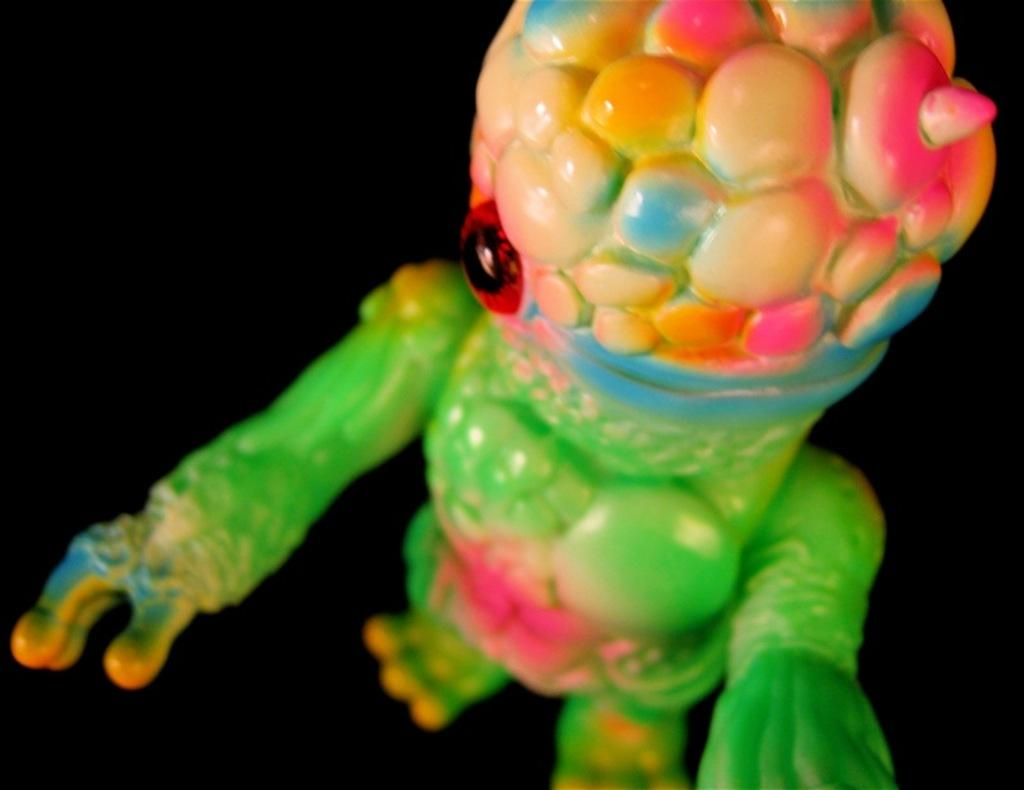What object can be seen in the image? There is a toy in the image. What can be observed about the background of the image? The background of the image is dark. What type of owl is sitting on the toy in the image? There is no owl present in the image; it only features a toy. Can you tell me how many boots are visible in the image? There are no boots present in the image. 